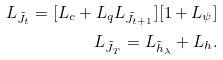<formula> <loc_0><loc_0><loc_500><loc_500>L _ { \tilde { J } _ { t } } = [ L _ { c } + L _ { q } L _ { \tilde { J } _ { t + 1 } } ] [ 1 + L _ { \psi } ] \\ L _ { \tilde { J } _ { T } } = L _ { \tilde { h } _ { \lambda } } + L _ { h } .</formula> 